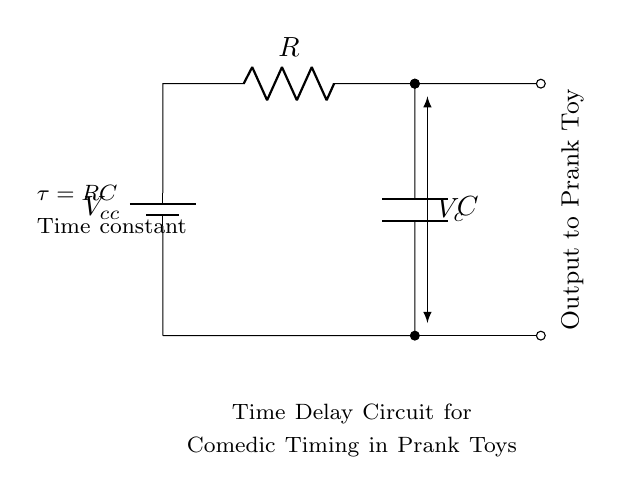What is the main function of this circuit? The main function is to create a time delay for comedic timing in prank toys, allowing a control delay before the toy activates.
Answer: Time delay What type of components are used in this circuit? The circuit includes a resistor and a capacitor, which are the essential components for creating a time constant in an RC circuit.
Answer: Resistor and capacitor What does the time constant of this circuit represent? The time constant, denoted as tau, is the product of resistance and capacitance (RC) and indicates how quickly the capacitor charges or discharges.
Answer: Tau What is the output of this circuit used for? The output is connected to the prank toy, which will receive the delayed signal to activate its comedic function after a set time interval.
Answer: Prank toy activation How does increasing the resistance value affect the time delay? Increasing the resistance value will increase the time constant (tau), resulting in a longer time delay before the prank toy activates.
Answer: Longer delay What happens when the capacitor is fully charged? When the capacitor is fully charged, the voltage across it reaches the supply voltage, which stops current flow through the resistor, effectively turning off the output until a reset occurs.
Answer: Stops current flow What is the effect of decreasing the capacitance in this circuit? Decreasing the capacitance leads to a shorter time constant (tau), causing the time delay before activation to decrease.
Answer: Shorter delay 